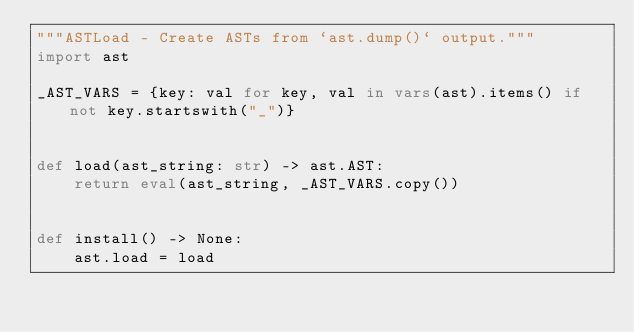<code> <loc_0><loc_0><loc_500><loc_500><_Python_>"""ASTLoad - Create ASTs from `ast.dump()` output."""
import ast

_AST_VARS = {key: val for key, val in vars(ast).items() if not key.startswith("_")}


def load(ast_string: str) -> ast.AST:
    return eval(ast_string, _AST_VARS.copy())


def install() -> None:
    ast.load = load
</code> 